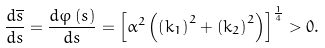<formula> <loc_0><loc_0><loc_500><loc_500>\frac { d \overline { s } } { d s } = \frac { d \varphi \left ( s \right ) } { d s } = \left [ \alpha ^ { 2 } \left ( \left ( k _ { 1 } \right ) ^ { 2 } + \left ( k _ { 2 } \right ) ^ { 2 } \right ) \right ] ^ { \frac { 1 } { 4 } } > 0 .</formula> 